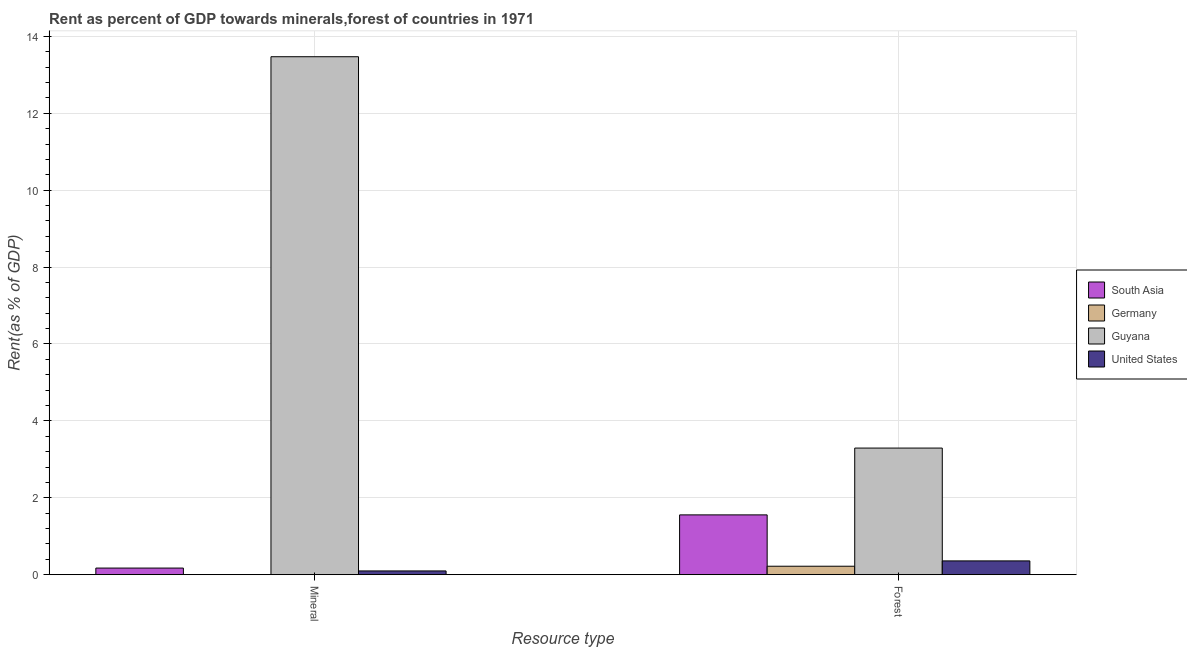Are the number of bars per tick equal to the number of legend labels?
Your answer should be very brief. Yes. Are the number of bars on each tick of the X-axis equal?
Offer a very short reply. Yes. How many bars are there on the 2nd tick from the left?
Ensure brevity in your answer.  4. What is the label of the 1st group of bars from the left?
Your answer should be compact. Mineral. What is the mineral rent in United States?
Ensure brevity in your answer.  0.1. Across all countries, what is the maximum forest rent?
Give a very brief answer. 3.29. Across all countries, what is the minimum mineral rent?
Provide a succinct answer. 0. In which country was the mineral rent maximum?
Your answer should be compact. Guyana. What is the total forest rent in the graph?
Give a very brief answer. 5.43. What is the difference between the forest rent in United States and that in South Asia?
Make the answer very short. -1.2. What is the difference between the mineral rent in Germany and the forest rent in Guyana?
Provide a short and direct response. -3.29. What is the average mineral rent per country?
Ensure brevity in your answer.  3.44. What is the difference between the mineral rent and forest rent in Guyana?
Offer a very short reply. 10.18. What is the ratio of the mineral rent in Guyana to that in South Asia?
Provide a short and direct response. 78.21. Is the mineral rent in South Asia less than that in Guyana?
Make the answer very short. Yes. What does the 3rd bar from the left in Mineral represents?
Give a very brief answer. Guyana. What does the 3rd bar from the right in Forest represents?
Offer a very short reply. Germany. Does the graph contain grids?
Keep it short and to the point. Yes. How many legend labels are there?
Your response must be concise. 4. How are the legend labels stacked?
Keep it short and to the point. Vertical. What is the title of the graph?
Your response must be concise. Rent as percent of GDP towards minerals,forest of countries in 1971. Does "Comoros" appear as one of the legend labels in the graph?
Make the answer very short. No. What is the label or title of the X-axis?
Offer a terse response. Resource type. What is the label or title of the Y-axis?
Offer a very short reply. Rent(as % of GDP). What is the Rent(as % of GDP) of South Asia in Mineral?
Your answer should be very brief. 0.17. What is the Rent(as % of GDP) of Germany in Mineral?
Offer a very short reply. 0. What is the Rent(as % of GDP) in Guyana in Mineral?
Give a very brief answer. 13.47. What is the Rent(as % of GDP) of United States in Mineral?
Give a very brief answer. 0.1. What is the Rent(as % of GDP) in South Asia in Forest?
Give a very brief answer. 1.56. What is the Rent(as % of GDP) of Germany in Forest?
Keep it short and to the point. 0.22. What is the Rent(as % of GDP) of Guyana in Forest?
Your response must be concise. 3.29. What is the Rent(as % of GDP) in United States in Forest?
Provide a short and direct response. 0.36. Across all Resource type, what is the maximum Rent(as % of GDP) in South Asia?
Offer a very short reply. 1.56. Across all Resource type, what is the maximum Rent(as % of GDP) in Germany?
Provide a short and direct response. 0.22. Across all Resource type, what is the maximum Rent(as % of GDP) of Guyana?
Provide a succinct answer. 13.47. Across all Resource type, what is the maximum Rent(as % of GDP) of United States?
Keep it short and to the point. 0.36. Across all Resource type, what is the minimum Rent(as % of GDP) in South Asia?
Your answer should be compact. 0.17. Across all Resource type, what is the minimum Rent(as % of GDP) of Germany?
Your answer should be compact. 0. Across all Resource type, what is the minimum Rent(as % of GDP) of Guyana?
Offer a terse response. 3.29. Across all Resource type, what is the minimum Rent(as % of GDP) of United States?
Your answer should be very brief. 0.1. What is the total Rent(as % of GDP) in South Asia in the graph?
Offer a very short reply. 1.73. What is the total Rent(as % of GDP) in Germany in the graph?
Provide a succinct answer. 0.22. What is the total Rent(as % of GDP) in Guyana in the graph?
Offer a very short reply. 16.76. What is the total Rent(as % of GDP) of United States in the graph?
Your response must be concise. 0.46. What is the difference between the Rent(as % of GDP) of South Asia in Mineral and that in Forest?
Make the answer very short. -1.38. What is the difference between the Rent(as % of GDP) in Germany in Mineral and that in Forest?
Your answer should be very brief. -0.22. What is the difference between the Rent(as % of GDP) of Guyana in Mineral and that in Forest?
Make the answer very short. 10.18. What is the difference between the Rent(as % of GDP) in United States in Mineral and that in Forest?
Your response must be concise. -0.26. What is the difference between the Rent(as % of GDP) of South Asia in Mineral and the Rent(as % of GDP) of Germany in Forest?
Offer a terse response. -0.05. What is the difference between the Rent(as % of GDP) in South Asia in Mineral and the Rent(as % of GDP) in Guyana in Forest?
Provide a succinct answer. -3.12. What is the difference between the Rent(as % of GDP) of South Asia in Mineral and the Rent(as % of GDP) of United States in Forest?
Make the answer very short. -0.19. What is the difference between the Rent(as % of GDP) of Germany in Mineral and the Rent(as % of GDP) of Guyana in Forest?
Provide a succinct answer. -3.29. What is the difference between the Rent(as % of GDP) of Germany in Mineral and the Rent(as % of GDP) of United States in Forest?
Give a very brief answer. -0.35. What is the difference between the Rent(as % of GDP) of Guyana in Mineral and the Rent(as % of GDP) of United States in Forest?
Your answer should be compact. 13.11. What is the average Rent(as % of GDP) of South Asia per Resource type?
Offer a very short reply. 0.86. What is the average Rent(as % of GDP) of Germany per Resource type?
Ensure brevity in your answer.  0.11. What is the average Rent(as % of GDP) in Guyana per Resource type?
Give a very brief answer. 8.38. What is the average Rent(as % of GDP) of United States per Resource type?
Ensure brevity in your answer.  0.23. What is the difference between the Rent(as % of GDP) of South Asia and Rent(as % of GDP) of Germany in Mineral?
Provide a succinct answer. 0.17. What is the difference between the Rent(as % of GDP) in South Asia and Rent(as % of GDP) in Guyana in Mineral?
Your answer should be very brief. -13.3. What is the difference between the Rent(as % of GDP) in South Asia and Rent(as % of GDP) in United States in Mineral?
Provide a succinct answer. 0.07. What is the difference between the Rent(as % of GDP) of Germany and Rent(as % of GDP) of Guyana in Mineral?
Give a very brief answer. -13.47. What is the difference between the Rent(as % of GDP) in Germany and Rent(as % of GDP) in United States in Mineral?
Offer a terse response. -0.09. What is the difference between the Rent(as % of GDP) in Guyana and Rent(as % of GDP) in United States in Mineral?
Your answer should be compact. 13.37. What is the difference between the Rent(as % of GDP) of South Asia and Rent(as % of GDP) of Germany in Forest?
Give a very brief answer. 1.34. What is the difference between the Rent(as % of GDP) of South Asia and Rent(as % of GDP) of Guyana in Forest?
Offer a very short reply. -1.74. What is the difference between the Rent(as % of GDP) in South Asia and Rent(as % of GDP) in United States in Forest?
Give a very brief answer. 1.2. What is the difference between the Rent(as % of GDP) in Germany and Rent(as % of GDP) in Guyana in Forest?
Give a very brief answer. -3.07. What is the difference between the Rent(as % of GDP) in Germany and Rent(as % of GDP) in United States in Forest?
Make the answer very short. -0.14. What is the difference between the Rent(as % of GDP) in Guyana and Rent(as % of GDP) in United States in Forest?
Provide a succinct answer. 2.93. What is the ratio of the Rent(as % of GDP) in South Asia in Mineral to that in Forest?
Offer a very short reply. 0.11. What is the ratio of the Rent(as % of GDP) in Germany in Mineral to that in Forest?
Your answer should be very brief. 0.02. What is the ratio of the Rent(as % of GDP) in Guyana in Mineral to that in Forest?
Offer a very short reply. 4.09. What is the ratio of the Rent(as % of GDP) of United States in Mineral to that in Forest?
Give a very brief answer. 0.27. What is the difference between the highest and the second highest Rent(as % of GDP) of South Asia?
Offer a very short reply. 1.38. What is the difference between the highest and the second highest Rent(as % of GDP) of Germany?
Your response must be concise. 0.22. What is the difference between the highest and the second highest Rent(as % of GDP) of Guyana?
Offer a terse response. 10.18. What is the difference between the highest and the second highest Rent(as % of GDP) of United States?
Provide a succinct answer. 0.26. What is the difference between the highest and the lowest Rent(as % of GDP) of South Asia?
Provide a succinct answer. 1.38. What is the difference between the highest and the lowest Rent(as % of GDP) of Germany?
Provide a short and direct response. 0.22. What is the difference between the highest and the lowest Rent(as % of GDP) of Guyana?
Ensure brevity in your answer.  10.18. What is the difference between the highest and the lowest Rent(as % of GDP) of United States?
Provide a succinct answer. 0.26. 